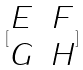Convert formula to latex. <formula><loc_0><loc_0><loc_500><loc_500>[ \begin{matrix} E & F \\ G & H \end{matrix} ]</formula> 